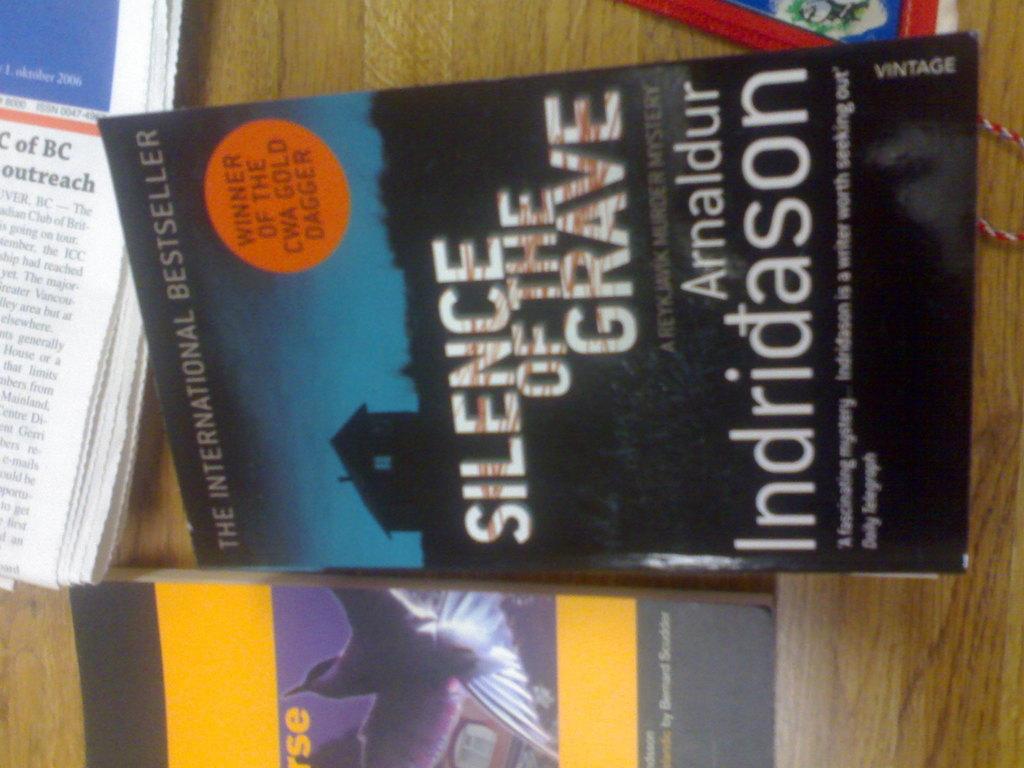Who wrote the book?
Your answer should be compact. Arnaldur indridason. What is the title of the book?
Ensure brevity in your answer.  Silence of the grave. 